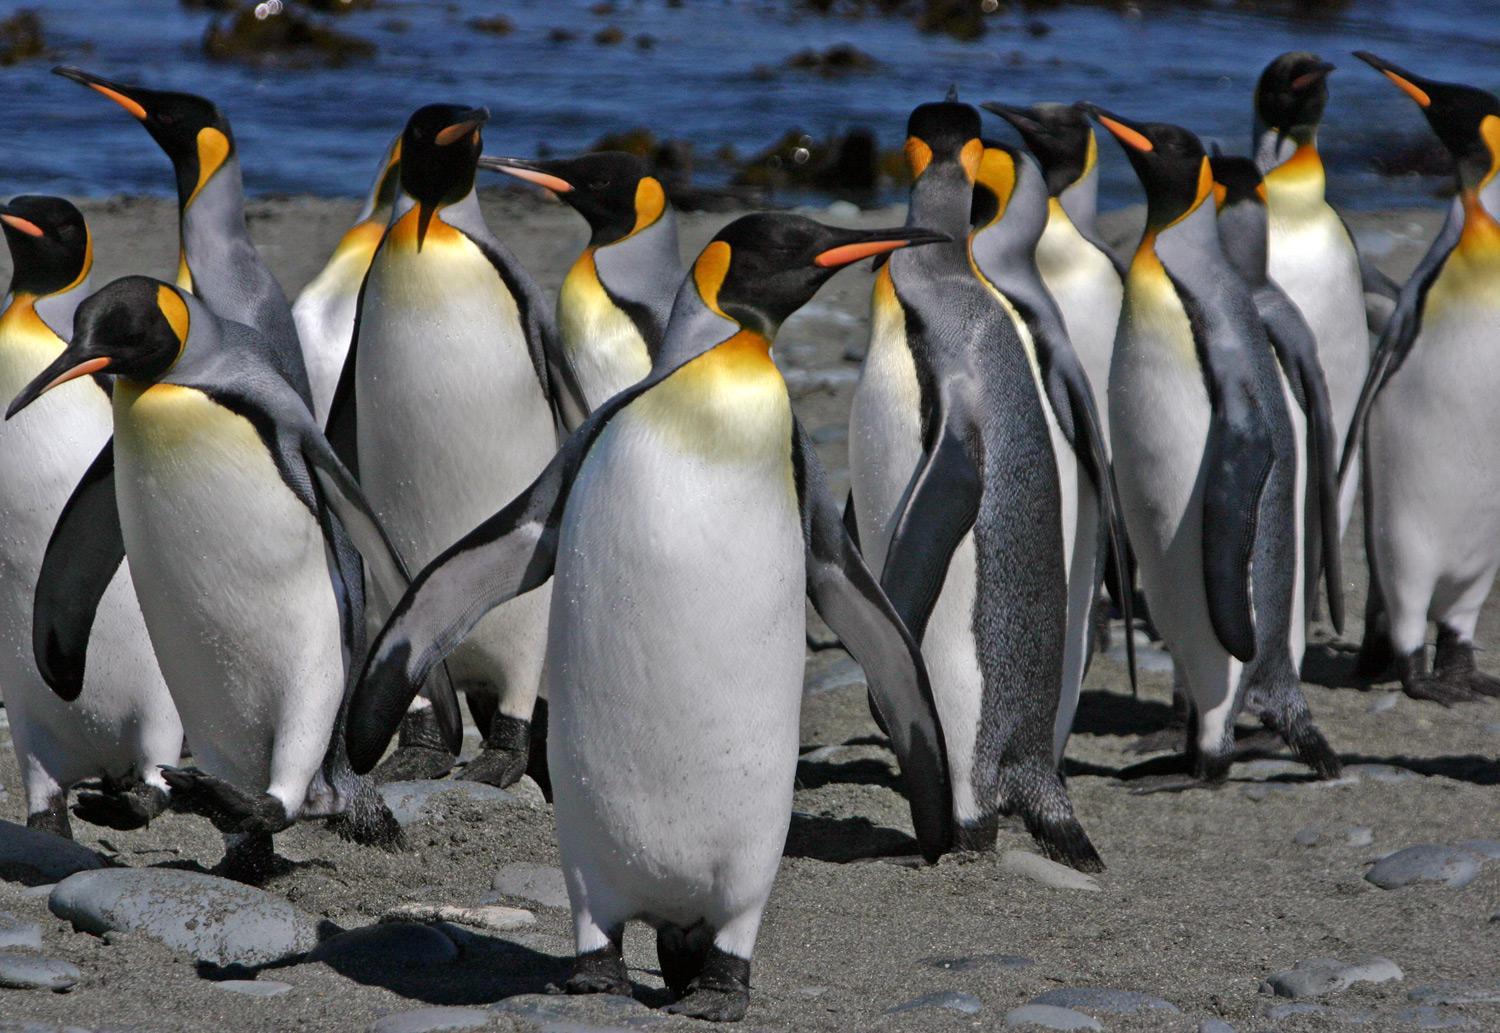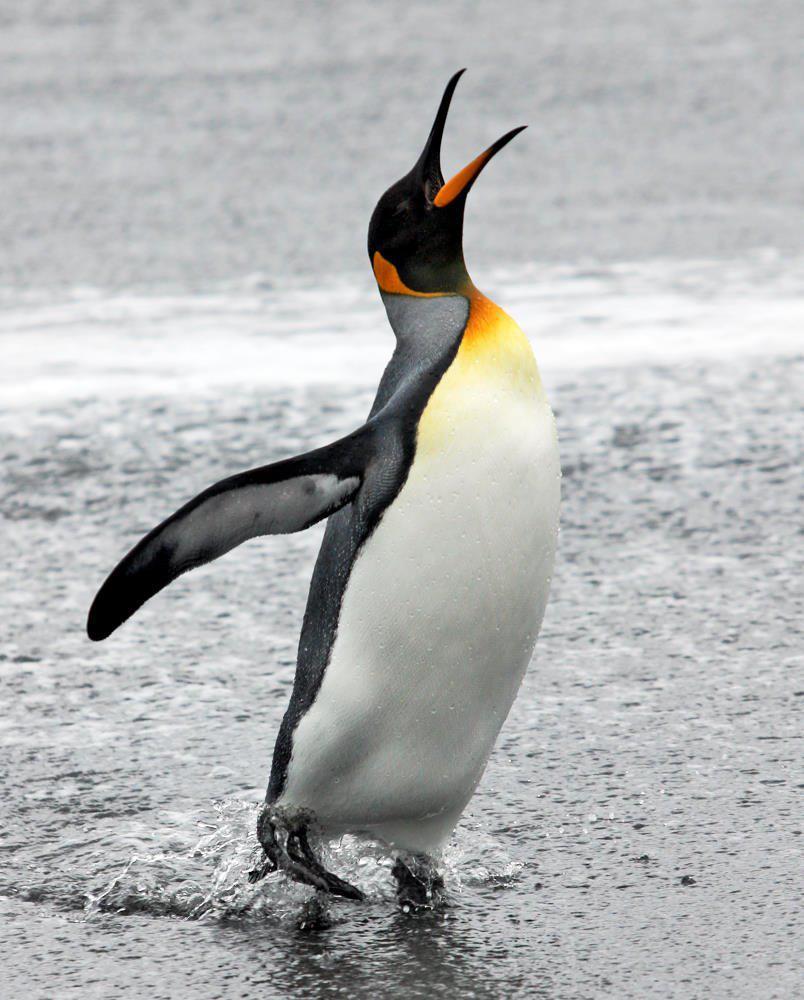The first image is the image on the left, the second image is the image on the right. Examine the images to the left and right. Is the description "There is exactly one penguin in the image on the right." accurate? Answer yes or no. Yes. 